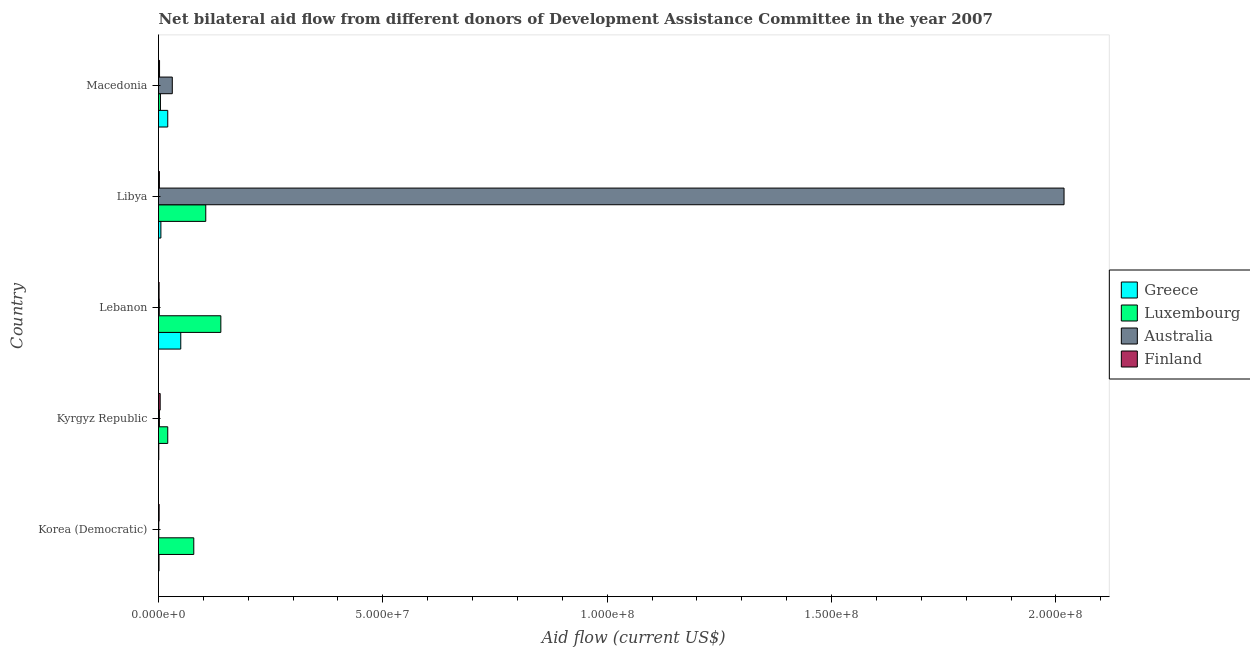How many different coloured bars are there?
Keep it short and to the point. 4. Are the number of bars per tick equal to the number of legend labels?
Your response must be concise. Yes. What is the label of the 3rd group of bars from the top?
Your answer should be compact. Lebanon. In how many cases, is the number of bars for a given country not equal to the number of legend labels?
Offer a terse response. 0. What is the amount of aid given by australia in Lebanon?
Keep it short and to the point. 1.70e+05. Across all countries, what is the maximum amount of aid given by finland?
Offer a very short reply. 3.70e+05. Across all countries, what is the minimum amount of aid given by finland?
Offer a terse response. 1.30e+05. In which country was the amount of aid given by greece maximum?
Provide a short and direct response. Lebanon. In which country was the amount of aid given by australia minimum?
Offer a terse response. Korea (Democratic). What is the total amount of aid given by luxembourg in the graph?
Provide a short and direct response. 3.48e+07. What is the difference between the amount of aid given by luxembourg in Lebanon and that in Libya?
Offer a terse response. 3.36e+06. What is the difference between the amount of aid given by greece in Lebanon and the amount of aid given by australia in Korea (Democratic)?
Make the answer very short. 4.90e+06. What is the average amount of aid given by australia per country?
Provide a succinct answer. 4.11e+07. What is the difference between the amount of aid given by luxembourg and amount of aid given by australia in Lebanon?
Your answer should be very brief. 1.37e+07. In how many countries, is the amount of aid given by greece greater than 20000000 US$?
Provide a succinct answer. 0. Is the amount of aid given by finland in Korea (Democratic) less than that in Macedonia?
Your answer should be very brief. Yes. What is the difference between the highest and the second highest amount of aid given by australia?
Give a very brief answer. 1.99e+08. What is the difference between the highest and the lowest amount of aid given by australia?
Ensure brevity in your answer.  2.02e+08. Is it the case that in every country, the sum of the amount of aid given by australia and amount of aid given by luxembourg is greater than the sum of amount of aid given by finland and amount of aid given by greece?
Offer a very short reply. Yes. What does the 3rd bar from the top in Lebanon represents?
Keep it short and to the point. Luxembourg. What does the 2nd bar from the bottom in Lebanon represents?
Give a very brief answer. Luxembourg. Are all the bars in the graph horizontal?
Your answer should be compact. Yes. What is the difference between two consecutive major ticks on the X-axis?
Keep it short and to the point. 5.00e+07. Are the values on the major ticks of X-axis written in scientific E-notation?
Offer a very short reply. Yes. Does the graph contain any zero values?
Give a very brief answer. No. How many legend labels are there?
Make the answer very short. 4. What is the title of the graph?
Your answer should be very brief. Net bilateral aid flow from different donors of Development Assistance Committee in the year 2007. What is the label or title of the Y-axis?
Provide a succinct answer. Country. What is the Aid flow (current US$) in Greece in Korea (Democratic)?
Your response must be concise. 1.10e+05. What is the Aid flow (current US$) of Luxembourg in Korea (Democratic)?
Ensure brevity in your answer.  7.86e+06. What is the Aid flow (current US$) in Australia in Korea (Democratic)?
Your response must be concise. 6.00e+04. What is the Aid flow (current US$) in Luxembourg in Kyrgyz Republic?
Make the answer very short. 2.06e+06. What is the Aid flow (current US$) in Greece in Lebanon?
Make the answer very short. 4.96e+06. What is the Aid flow (current US$) in Luxembourg in Lebanon?
Offer a very short reply. 1.39e+07. What is the Aid flow (current US$) in Australia in Lebanon?
Offer a very short reply. 1.70e+05. What is the Aid flow (current US$) of Greece in Libya?
Ensure brevity in your answer.  5.30e+05. What is the Aid flow (current US$) of Luxembourg in Libya?
Offer a very short reply. 1.05e+07. What is the Aid flow (current US$) of Australia in Libya?
Your answer should be very brief. 2.02e+08. What is the Aid flow (current US$) of Finland in Libya?
Offer a terse response. 2.00e+05. What is the Aid flow (current US$) of Greece in Macedonia?
Keep it short and to the point. 2.06e+06. What is the Aid flow (current US$) of Australia in Macedonia?
Your response must be concise. 3.07e+06. What is the Aid flow (current US$) in Finland in Macedonia?
Give a very brief answer. 2.30e+05. Across all countries, what is the maximum Aid flow (current US$) of Greece?
Keep it short and to the point. 4.96e+06. Across all countries, what is the maximum Aid flow (current US$) in Luxembourg?
Give a very brief answer. 1.39e+07. Across all countries, what is the maximum Aid flow (current US$) of Australia?
Offer a very short reply. 2.02e+08. Across all countries, what is the minimum Aid flow (current US$) of Greece?
Your answer should be compact. 6.00e+04. Across all countries, what is the minimum Aid flow (current US$) in Luxembourg?
Offer a very short reply. 4.30e+05. Across all countries, what is the minimum Aid flow (current US$) of Australia?
Make the answer very short. 6.00e+04. Across all countries, what is the minimum Aid flow (current US$) of Finland?
Ensure brevity in your answer.  1.30e+05. What is the total Aid flow (current US$) in Greece in the graph?
Offer a very short reply. 7.72e+06. What is the total Aid flow (current US$) in Luxembourg in the graph?
Your answer should be very brief. 3.48e+07. What is the total Aid flow (current US$) of Australia in the graph?
Provide a short and direct response. 2.05e+08. What is the total Aid flow (current US$) in Finland in the graph?
Give a very brief answer. 1.07e+06. What is the difference between the Aid flow (current US$) of Greece in Korea (Democratic) and that in Kyrgyz Republic?
Your response must be concise. 5.00e+04. What is the difference between the Aid flow (current US$) of Luxembourg in Korea (Democratic) and that in Kyrgyz Republic?
Ensure brevity in your answer.  5.80e+06. What is the difference between the Aid flow (current US$) of Australia in Korea (Democratic) and that in Kyrgyz Republic?
Give a very brief answer. -1.40e+05. What is the difference between the Aid flow (current US$) of Greece in Korea (Democratic) and that in Lebanon?
Ensure brevity in your answer.  -4.85e+06. What is the difference between the Aid flow (current US$) of Luxembourg in Korea (Democratic) and that in Lebanon?
Keep it short and to the point. -6.03e+06. What is the difference between the Aid flow (current US$) in Australia in Korea (Democratic) and that in Lebanon?
Your answer should be compact. -1.10e+05. What is the difference between the Aid flow (current US$) of Greece in Korea (Democratic) and that in Libya?
Make the answer very short. -4.20e+05. What is the difference between the Aid flow (current US$) of Luxembourg in Korea (Democratic) and that in Libya?
Provide a succinct answer. -2.67e+06. What is the difference between the Aid flow (current US$) of Australia in Korea (Democratic) and that in Libya?
Offer a terse response. -2.02e+08. What is the difference between the Aid flow (current US$) of Greece in Korea (Democratic) and that in Macedonia?
Your answer should be compact. -1.95e+06. What is the difference between the Aid flow (current US$) in Luxembourg in Korea (Democratic) and that in Macedonia?
Provide a succinct answer. 7.43e+06. What is the difference between the Aid flow (current US$) of Australia in Korea (Democratic) and that in Macedonia?
Ensure brevity in your answer.  -3.01e+06. What is the difference between the Aid flow (current US$) in Finland in Korea (Democratic) and that in Macedonia?
Provide a succinct answer. -9.00e+04. What is the difference between the Aid flow (current US$) in Greece in Kyrgyz Republic and that in Lebanon?
Ensure brevity in your answer.  -4.90e+06. What is the difference between the Aid flow (current US$) in Luxembourg in Kyrgyz Republic and that in Lebanon?
Your answer should be compact. -1.18e+07. What is the difference between the Aid flow (current US$) of Australia in Kyrgyz Republic and that in Lebanon?
Provide a succinct answer. 3.00e+04. What is the difference between the Aid flow (current US$) of Finland in Kyrgyz Republic and that in Lebanon?
Your answer should be compact. 2.40e+05. What is the difference between the Aid flow (current US$) of Greece in Kyrgyz Republic and that in Libya?
Provide a short and direct response. -4.70e+05. What is the difference between the Aid flow (current US$) in Luxembourg in Kyrgyz Republic and that in Libya?
Provide a short and direct response. -8.47e+06. What is the difference between the Aid flow (current US$) in Australia in Kyrgyz Republic and that in Libya?
Your answer should be compact. -2.02e+08. What is the difference between the Aid flow (current US$) in Finland in Kyrgyz Republic and that in Libya?
Offer a terse response. 1.70e+05. What is the difference between the Aid flow (current US$) of Luxembourg in Kyrgyz Republic and that in Macedonia?
Your response must be concise. 1.63e+06. What is the difference between the Aid flow (current US$) of Australia in Kyrgyz Republic and that in Macedonia?
Give a very brief answer. -2.87e+06. What is the difference between the Aid flow (current US$) in Greece in Lebanon and that in Libya?
Your response must be concise. 4.43e+06. What is the difference between the Aid flow (current US$) in Luxembourg in Lebanon and that in Libya?
Provide a short and direct response. 3.36e+06. What is the difference between the Aid flow (current US$) in Australia in Lebanon and that in Libya?
Offer a very short reply. -2.02e+08. What is the difference between the Aid flow (current US$) of Greece in Lebanon and that in Macedonia?
Your response must be concise. 2.90e+06. What is the difference between the Aid flow (current US$) of Luxembourg in Lebanon and that in Macedonia?
Provide a succinct answer. 1.35e+07. What is the difference between the Aid flow (current US$) in Australia in Lebanon and that in Macedonia?
Your response must be concise. -2.90e+06. What is the difference between the Aid flow (current US$) of Greece in Libya and that in Macedonia?
Your answer should be very brief. -1.53e+06. What is the difference between the Aid flow (current US$) in Luxembourg in Libya and that in Macedonia?
Keep it short and to the point. 1.01e+07. What is the difference between the Aid flow (current US$) of Australia in Libya and that in Macedonia?
Offer a terse response. 1.99e+08. What is the difference between the Aid flow (current US$) of Greece in Korea (Democratic) and the Aid flow (current US$) of Luxembourg in Kyrgyz Republic?
Ensure brevity in your answer.  -1.95e+06. What is the difference between the Aid flow (current US$) of Greece in Korea (Democratic) and the Aid flow (current US$) of Australia in Kyrgyz Republic?
Offer a terse response. -9.00e+04. What is the difference between the Aid flow (current US$) in Luxembourg in Korea (Democratic) and the Aid flow (current US$) in Australia in Kyrgyz Republic?
Make the answer very short. 7.66e+06. What is the difference between the Aid flow (current US$) in Luxembourg in Korea (Democratic) and the Aid flow (current US$) in Finland in Kyrgyz Republic?
Ensure brevity in your answer.  7.49e+06. What is the difference between the Aid flow (current US$) of Australia in Korea (Democratic) and the Aid flow (current US$) of Finland in Kyrgyz Republic?
Your response must be concise. -3.10e+05. What is the difference between the Aid flow (current US$) of Greece in Korea (Democratic) and the Aid flow (current US$) of Luxembourg in Lebanon?
Keep it short and to the point. -1.38e+07. What is the difference between the Aid flow (current US$) of Greece in Korea (Democratic) and the Aid flow (current US$) of Australia in Lebanon?
Your answer should be very brief. -6.00e+04. What is the difference between the Aid flow (current US$) of Greece in Korea (Democratic) and the Aid flow (current US$) of Finland in Lebanon?
Keep it short and to the point. -2.00e+04. What is the difference between the Aid flow (current US$) in Luxembourg in Korea (Democratic) and the Aid flow (current US$) in Australia in Lebanon?
Provide a short and direct response. 7.69e+06. What is the difference between the Aid flow (current US$) of Luxembourg in Korea (Democratic) and the Aid flow (current US$) of Finland in Lebanon?
Give a very brief answer. 7.73e+06. What is the difference between the Aid flow (current US$) of Australia in Korea (Democratic) and the Aid flow (current US$) of Finland in Lebanon?
Your response must be concise. -7.00e+04. What is the difference between the Aid flow (current US$) in Greece in Korea (Democratic) and the Aid flow (current US$) in Luxembourg in Libya?
Your answer should be compact. -1.04e+07. What is the difference between the Aid flow (current US$) of Greece in Korea (Democratic) and the Aid flow (current US$) of Australia in Libya?
Your response must be concise. -2.02e+08. What is the difference between the Aid flow (current US$) of Greece in Korea (Democratic) and the Aid flow (current US$) of Finland in Libya?
Offer a very short reply. -9.00e+04. What is the difference between the Aid flow (current US$) in Luxembourg in Korea (Democratic) and the Aid flow (current US$) in Australia in Libya?
Your response must be concise. -1.94e+08. What is the difference between the Aid flow (current US$) in Luxembourg in Korea (Democratic) and the Aid flow (current US$) in Finland in Libya?
Offer a terse response. 7.66e+06. What is the difference between the Aid flow (current US$) of Greece in Korea (Democratic) and the Aid flow (current US$) of Luxembourg in Macedonia?
Your answer should be compact. -3.20e+05. What is the difference between the Aid flow (current US$) of Greece in Korea (Democratic) and the Aid flow (current US$) of Australia in Macedonia?
Keep it short and to the point. -2.96e+06. What is the difference between the Aid flow (current US$) in Greece in Korea (Democratic) and the Aid flow (current US$) in Finland in Macedonia?
Offer a very short reply. -1.20e+05. What is the difference between the Aid flow (current US$) in Luxembourg in Korea (Democratic) and the Aid flow (current US$) in Australia in Macedonia?
Your response must be concise. 4.79e+06. What is the difference between the Aid flow (current US$) in Luxembourg in Korea (Democratic) and the Aid flow (current US$) in Finland in Macedonia?
Your answer should be very brief. 7.63e+06. What is the difference between the Aid flow (current US$) of Greece in Kyrgyz Republic and the Aid flow (current US$) of Luxembourg in Lebanon?
Ensure brevity in your answer.  -1.38e+07. What is the difference between the Aid flow (current US$) of Greece in Kyrgyz Republic and the Aid flow (current US$) of Australia in Lebanon?
Offer a very short reply. -1.10e+05. What is the difference between the Aid flow (current US$) of Greece in Kyrgyz Republic and the Aid flow (current US$) of Finland in Lebanon?
Keep it short and to the point. -7.00e+04. What is the difference between the Aid flow (current US$) in Luxembourg in Kyrgyz Republic and the Aid flow (current US$) in Australia in Lebanon?
Your answer should be compact. 1.89e+06. What is the difference between the Aid flow (current US$) in Luxembourg in Kyrgyz Republic and the Aid flow (current US$) in Finland in Lebanon?
Your response must be concise. 1.93e+06. What is the difference between the Aid flow (current US$) of Greece in Kyrgyz Republic and the Aid flow (current US$) of Luxembourg in Libya?
Your response must be concise. -1.05e+07. What is the difference between the Aid flow (current US$) of Greece in Kyrgyz Republic and the Aid flow (current US$) of Australia in Libya?
Make the answer very short. -2.02e+08. What is the difference between the Aid flow (current US$) of Greece in Kyrgyz Republic and the Aid flow (current US$) of Finland in Libya?
Ensure brevity in your answer.  -1.40e+05. What is the difference between the Aid flow (current US$) in Luxembourg in Kyrgyz Republic and the Aid flow (current US$) in Australia in Libya?
Give a very brief answer. -2.00e+08. What is the difference between the Aid flow (current US$) of Luxembourg in Kyrgyz Republic and the Aid flow (current US$) of Finland in Libya?
Give a very brief answer. 1.86e+06. What is the difference between the Aid flow (current US$) of Australia in Kyrgyz Republic and the Aid flow (current US$) of Finland in Libya?
Give a very brief answer. 0. What is the difference between the Aid flow (current US$) of Greece in Kyrgyz Republic and the Aid flow (current US$) of Luxembourg in Macedonia?
Provide a short and direct response. -3.70e+05. What is the difference between the Aid flow (current US$) in Greece in Kyrgyz Republic and the Aid flow (current US$) in Australia in Macedonia?
Keep it short and to the point. -3.01e+06. What is the difference between the Aid flow (current US$) in Greece in Kyrgyz Republic and the Aid flow (current US$) in Finland in Macedonia?
Provide a short and direct response. -1.70e+05. What is the difference between the Aid flow (current US$) in Luxembourg in Kyrgyz Republic and the Aid flow (current US$) in Australia in Macedonia?
Your response must be concise. -1.01e+06. What is the difference between the Aid flow (current US$) in Luxembourg in Kyrgyz Republic and the Aid flow (current US$) in Finland in Macedonia?
Ensure brevity in your answer.  1.83e+06. What is the difference between the Aid flow (current US$) in Australia in Kyrgyz Republic and the Aid flow (current US$) in Finland in Macedonia?
Ensure brevity in your answer.  -3.00e+04. What is the difference between the Aid flow (current US$) in Greece in Lebanon and the Aid flow (current US$) in Luxembourg in Libya?
Give a very brief answer. -5.57e+06. What is the difference between the Aid flow (current US$) of Greece in Lebanon and the Aid flow (current US$) of Australia in Libya?
Your response must be concise. -1.97e+08. What is the difference between the Aid flow (current US$) in Greece in Lebanon and the Aid flow (current US$) in Finland in Libya?
Your answer should be compact. 4.76e+06. What is the difference between the Aid flow (current US$) in Luxembourg in Lebanon and the Aid flow (current US$) in Australia in Libya?
Give a very brief answer. -1.88e+08. What is the difference between the Aid flow (current US$) in Luxembourg in Lebanon and the Aid flow (current US$) in Finland in Libya?
Offer a very short reply. 1.37e+07. What is the difference between the Aid flow (current US$) of Greece in Lebanon and the Aid flow (current US$) of Luxembourg in Macedonia?
Provide a succinct answer. 4.53e+06. What is the difference between the Aid flow (current US$) of Greece in Lebanon and the Aid flow (current US$) of Australia in Macedonia?
Your answer should be very brief. 1.89e+06. What is the difference between the Aid flow (current US$) in Greece in Lebanon and the Aid flow (current US$) in Finland in Macedonia?
Provide a succinct answer. 4.73e+06. What is the difference between the Aid flow (current US$) in Luxembourg in Lebanon and the Aid flow (current US$) in Australia in Macedonia?
Offer a terse response. 1.08e+07. What is the difference between the Aid flow (current US$) of Luxembourg in Lebanon and the Aid flow (current US$) of Finland in Macedonia?
Offer a very short reply. 1.37e+07. What is the difference between the Aid flow (current US$) in Australia in Lebanon and the Aid flow (current US$) in Finland in Macedonia?
Keep it short and to the point. -6.00e+04. What is the difference between the Aid flow (current US$) of Greece in Libya and the Aid flow (current US$) of Luxembourg in Macedonia?
Keep it short and to the point. 1.00e+05. What is the difference between the Aid flow (current US$) of Greece in Libya and the Aid flow (current US$) of Australia in Macedonia?
Ensure brevity in your answer.  -2.54e+06. What is the difference between the Aid flow (current US$) of Luxembourg in Libya and the Aid flow (current US$) of Australia in Macedonia?
Your response must be concise. 7.46e+06. What is the difference between the Aid flow (current US$) of Luxembourg in Libya and the Aid flow (current US$) of Finland in Macedonia?
Offer a very short reply. 1.03e+07. What is the difference between the Aid flow (current US$) of Australia in Libya and the Aid flow (current US$) of Finland in Macedonia?
Offer a very short reply. 2.02e+08. What is the average Aid flow (current US$) in Greece per country?
Your response must be concise. 1.54e+06. What is the average Aid flow (current US$) of Luxembourg per country?
Keep it short and to the point. 6.95e+06. What is the average Aid flow (current US$) in Australia per country?
Ensure brevity in your answer.  4.11e+07. What is the average Aid flow (current US$) of Finland per country?
Offer a terse response. 2.14e+05. What is the difference between the Aid flow (current US$) of Greece and Aid flow (current US$) of Luxembourg in Korea (Democratic)?
Ensure brevity in your answer.  -7.75e+06. What is the difference between the Aid flow (current US$) of Greece and Aid flow (current US$) of Finland in Korea (Democratic)?
Ensure brevity in your answer.  -3.00e+04. What is the difference between the Aid flow (current US$) in Luxembourg and Aid flow (current US$) in Australia in Korea (Democratic)?
Ensure brevity in your answer.  7.80e+06. What is the difference between the Aid flow (current US$) of Luxembourg and Aid flow (current US$) of Finland in Korea (Democratic)?
Offer a very short reply. 7.72e+06. What is the difference between the Aid flow (current US$) of Greece and Aid flow (current US$) of Luxembourg in Kyrgyz Republic?
Your answer should be compact. -2.00e+06. What is the difference between the Aid flow (current US$) in Greece and Aid flow (current US$) in Finland in Kyrgyz Republic?
Ensure brevity in your answer.  -3.10e+05. What is the difference between the Aid flow (current US$) of Luxembourg and Aid flow (current US$) of Australia in Kyrgyz Republic?
Make the answer very short. 1.86e+06. What is the difference between the Aid flow (current US$) of Luxembourg and Aid flow (current US$) of Finland in Kyrgyz Republic?
Your response must be concise. 1.69e+06. What is the difference between the Aid flow (current US$) of Australia and Aid flow (current US$) of Finland in Kyrgyz Republic?
Give a very brief answer. -1.70e+05. What is the difference between the Aid flow (current US$) in Greece and Aid flow (current US$) in Luxembourg in Lebanon?
Make the answer very short. -8.93e+06. What is the difference between the Aid flow (current US$) of Greece and Aid flow (current US$) of Australia in Lebanon?
Keep it short and to the point. 4.79e+06. What is the difference between the Aid flow (current US$) of Greece and Aid flow (current US$) of Finland in Lebanon?
Offer a very short reply. 4.83e+06. What is the difference between the Aid flow (current US$) in Luxembourg and Aid flow (current US$) in Australia in Lebanon?
Keep it short and to the point. 1.37e+07. What is the difference between the Aid flow (current US$) in Luxembourg and Aid flow (current US$) in Finland in Lebanon?
Provide a short and direct response. 1.38e+07. What is the difference between the Aid flow (current US$) in Greece and Aid flow (current US$) in Luxembourg in Libya?
Offer a terse response. -1.00e+07. What is the difference between the Aid flow (current US$) of Greece and Aid flow (current US$) of Australia in Libya?
Keep it short and to the point. -2.01e+08. What is the difference between the Aid flow (current US$) of Luxembourg and Aid flow (current US$) of Australia in Libya?
Provide a short and direct response. -1.91e+08. What is the difference between the Aid flow (current US$) of Luxembourg and Aid flow (current US$) of Finland in Libya?
Your answer should be compact. 1.03e+07. What is the difference between the Aid flow (current US$) in Australia and Aid flow (current US$) in Finland in Libya?
Offer a very short reply. 2.02e+08. What is the difference between the Aid flow (current US$) of Greece and Aid flow (current US$) of Luxembourg in Macedonia?
Offer a very short reply. 1.63e+06. What is the difference between the Aid flow (current US$) of Greece and Aid flow (current US$) of Australia in Macedonia?
Provide a short and direct response. -1.01e+06. What is the difference between the Aid flow (current US$) in Greece and Aid flow (current US$) in Finland in Macedonia?
Offer a very short reply. 1.83e+06. What is the difference between the Aid flow (current US$) of Luxembourg and Aid flow (current US$) of Australia in Macedonia?
Give a very brief answer. -2.64e+06. What is the difference between the Aid flow (current US$) of Australia and Aid flow (current US$) of Finland in Macedonia?
Offer a terse response. 2.84e+06. What is the ratio of the Aid flow (current US$) of Greece in Korea (Democratic) to that in Kyrgyz Republic?
Ensure brevity in your answer.  1.83. What is the ratio of the Aid flow (current US$) of Luxembourg in Korea (Democratic) to that in Kyrgyz Republic?
Keep it short and to the point. 3.82. What is the ratio of the Aid flow (current US$) of Australia in Korea (Democratic) to that in Kyrgyz Republic?
Give a very brief answer. 0.3. What is the ratio of the Aid flow (current US$) in Finland in Korea (Democratic) to that in Kyrgyz Republic?
Offer a terse response. 0.38. What is the ratio of the Aid flow (current US$) in Greece in Korea (Democratic) to that in Lebanon?
Give a very brief answer. 0.02. What is the ratio of the Aid flow (current US$) in Luxembourg in Korea (Democratic) to that in Lebanon?
Ensure brevity in your answer.  0.57. What is the ratio of the Aid flow (current US$) in Australia in Korea (Democratic) to that in Lebanon?
Provide a succinct answer. 0.35. What is the ratio of the Aid flow (current US$) in Greece in Korea (Democratic) to that in Libya?
Ensure brevity in your answer.  0.21. What is the ratio of the Aid flow (current US$) of Luxembourg in Korea (Democratic) to that in Libya?
Provide a succinct answer. 0.75. What is the ratio of the Aid flow (current US$) of Finland in Korea (Democratic) to that in Libya?
Your answer should be compact. 0.7. What is the ratio of the Aid flow (current US$) of Greece in Korea (Democratic) to that in Macedonia?
Ensure brevity in your answer.  0.05. What is the ratio of the Aid flow (current US$) of Luxembourg in Korea (Democratic) to that in Macedonia?
Offer a very short reply. 18.28. What is the ratio of the Aid flow (current US$) in Australia in Korea (Democratic) to that in Macedonia?
Keep it short and to the point. 0.02. What is the ratio of the Aid flow (current US$) of Finland in Korea (Democratic) to that in Macedonia?
Offer a very short reply. 0.61. What is the ratio of the Aid flow (current US$) of Greece in Kyrgyz Republic to that in Lebanon?
Offer a terse response. 0.01. What is the ratio of the Aid flow (current US$) of Luxembourg in Kyrgyz Republic to that in Lebanon?
Ensure brevity in your answer.  0.15. What is the ratio of the Aid flow (current US$) of Australia in Kyrgyz Republic to that in Lebanon?
Provide a succinct answer. 1.18. What is the ratio of the Aid flow (current US$) of Finland in Kyrgyz Republic to that in Lebanon?
Your answer should be very brief. 2.85. What is the ratio of the Aid flow (current US$) of Greece in Kyrgyz Republic to that in Libya?
Keep it short and to the point. 0.11. What is the ratio of the Aid flow (current US$) in Luxembourg in Kyrgyz Republic to that in Libya?
Your answer should be compact. 0.2. What is the ratio of the Aid flow (current US$) of Australia in Kyrgyz Republic to that in Libya?
Offer a very short reply. 0. What is the ratio of the Aid flow (current US$) in Finland in Kyrgyz Republic to that in Libya?
Your answer should be compact. 1.85. What is the ratio of the Aid flow (current US$) in Greece in Kyrgyz Republic to that in Macedonia?
Give a very brief answer. 0.03. What is the ratio of the Aid flow (current US$) in Luxembourg in Kyrgyz Republic to that in Macedonia?
Keep it short and to the point. 4.79. What is the ratio of the Aid flow (current US$) in Australia in Kyrgyz Republic to that in Macedonia?
Give a very brief answer. 0.07. What is the ratio of the Aid flow (current US$) of Finland in Kyrgyz Republic to that in Macedonia?
Keep it short and to the point. 1.61. What is the ratio of the Aid flow (current US$) of Greece in Lebanon to that in Libya?
Give a very brief answer. 9.36. What is the ratio of the Aid flow (current US$) of Luxembourg in Lebanon to that in Libya?
Give a very brief answer. 1.32. What is the ratio of the Aid flow (current US$) in Australia in Lebanon to that in Libya?
Make the answer very short. 0. What is the ratio of the Aid flow (current US$) in Finland in Lebanon to that in Libya?
Your answer should be compact. 0.65. What is the ratio of the Aid flow (current US$) of Greece in Lebanon to that in Macedonia?
Provide a short and direct response. 2.41. What is the ratio of the Aid flow (current US$) of Luxembourg in Lebanon to that in Macedonia?
Keep it short and to the point. 32.3. What is the ratio of the Aid flow (current US$) of Australia in Lebanon to that in Macedonia?
Your response must be concise. 0.06. What is the ratio of the Aid flow (current US$) of Finland in Lebanon to that in Macedonia?
Offer a terse response. 0.57. What is the ratio of the Aid flow (current US$) in Greece in Libya to that in Macedonia?
Your answer should be compact. 0.26. What is the ratio of the Aid flow (current US$) in Luxembourg in Libya to that in Macedonia?
Offer a very short reply. 24.49. What is the ratio of the Aid flow (current US$) in Australia in Libya to that in Macedonia?
Your answer should be very brief. 65.74. What is the ratio of the Aid flow (current US$) in Finland in Libya to that in Macedonia?
Provide a succinct answer. 0.87. What is the difference between the highest and the second highest Aid flow (current US$) of Greece?
Provide a succinct answer. 2.90e+06. What is the difference between the highest and the second highest Aid flow (current US$) in Luxembourg?
Ensure brevity in your answer.  3.36e+06. What is the difference between the highest and the second highest Aid flow (current US$) in Australia?
Give a very brief answer. 1.99e+08. What is the difference between the highest and the lowest Aid flow (current US$) in Greece?
Your answer should be very brief. 4.90e+06. What is the difference between the highest and the lowest Aid flow (current US$) in Luxembourg?
Your answer should be compact. 1.35e+07. What is the difference between the highest and the lowest Aid flow (current US$) in Australia?
Provide a succinct answer. 2.02e+08. 